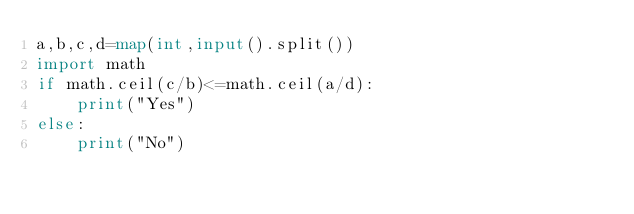Convert code to text. <code><loc_0><loc_0><loc_500><loc_500><_Python_>a,b,c,d=map(int,input().split())
import math
if math.ceil(c/b)<=math.ceil(a/d):
    print("Yes")
else:
    print("No")</code> 